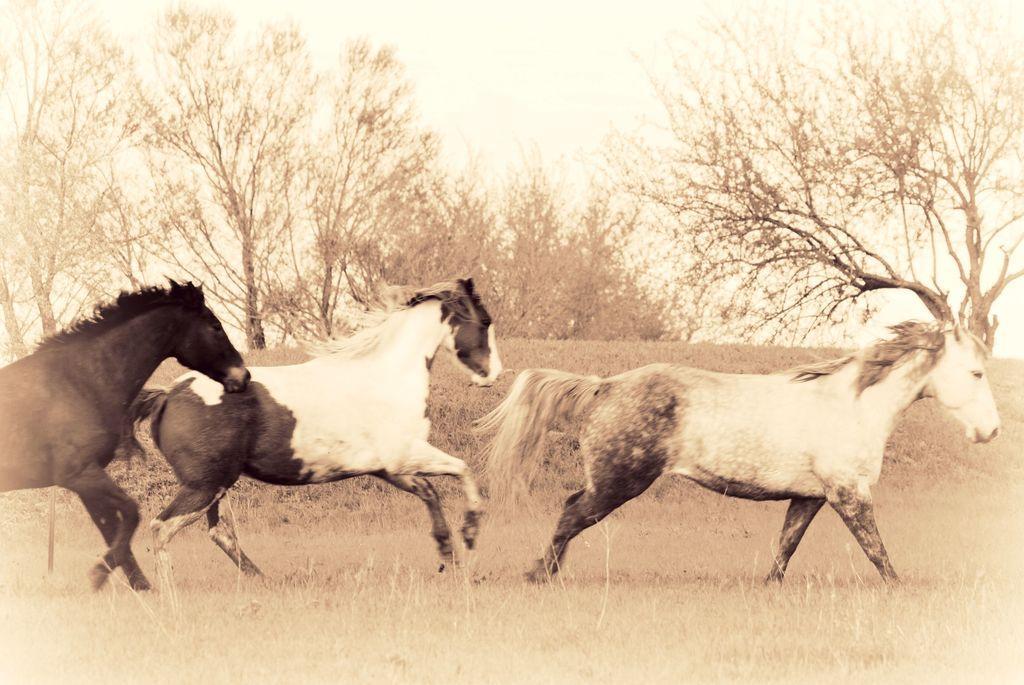Describe this image in one or two sentences. In this picture we can see horses on the ground and in the background we can see trees. 